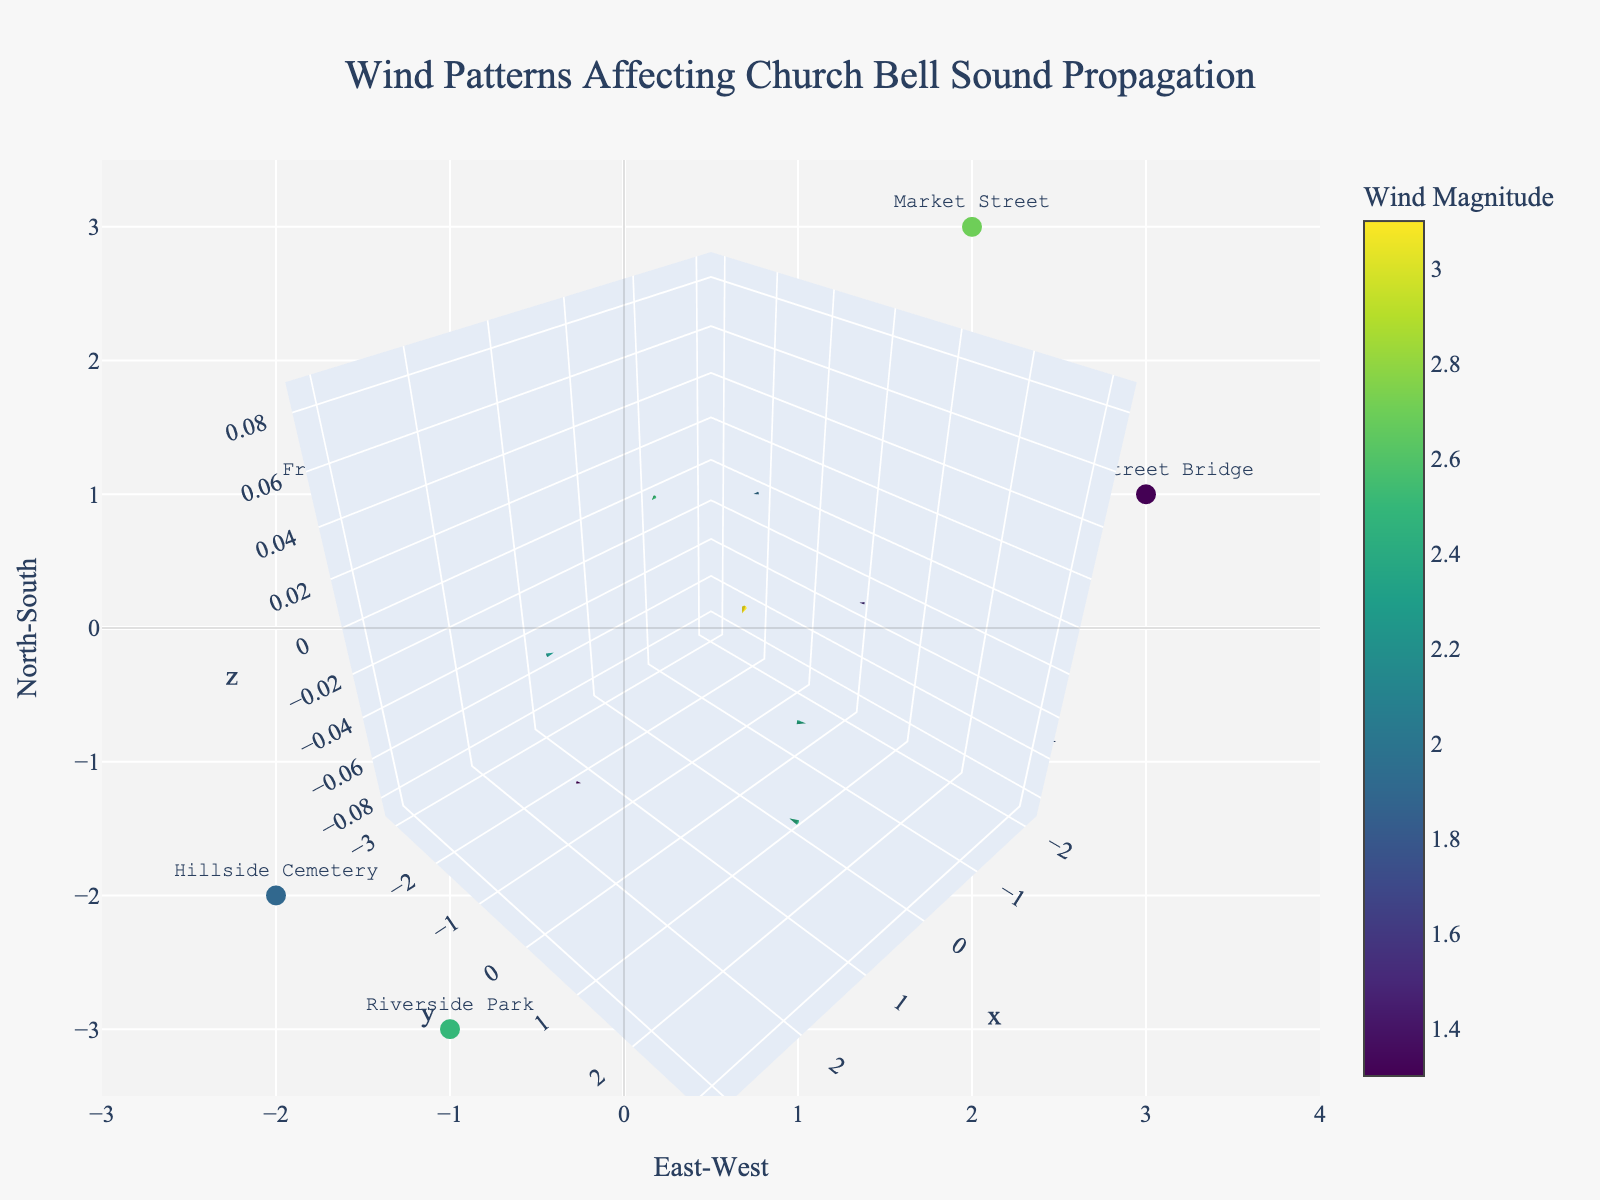How many locations are shown in the plot? There are markers scattered across the locations, each representing one point. Counting the number of names listed for locations, we find that the total number is 8.
Answer: 8 Which location exhibits the highest wind magnitude? The color of the markers indicates the wind magnitude, with Market Street showing the highest magnitude because its color halfway up the colorscale implies the highest value.
Answer: Market Street What direction does the wind move at the Old Mill Creek? Observing the arrow for Old Mill Creek, we see it points leftward (westward) with a slight upward tilt. Therefore, the wind direction is west-northwest.
Answer: West-northwest Compare the wind magnitudes at St. Mary's Church and Riverside Park; which is stronger? The marker colors for magnitude are compared, with St. Mary's Church showing a lighter color than Riverside Park. This means Riverside Park has a stronger wind magnitude.
Answer: Riverside Park What is the average wind magnitude across all locations? All given magnitudes are 3.1, 2.6, 1.7, 2.2, 1.9, 1.3, 2.5, 2.7. Summing these gives 3.1 + 2.6 + 1.7 + 2.2 + 1.9 + 1.3 + 2.5 + 2.7 = 18, and dividing by the number of locations (8), the average magnitude is 18/8.
Answer: 2.25 Which location has the wind blowing in the opposite direction of St. Mary's Church? The arrow at St. Mary's Church points to the northeast (NE), implying the wind blows toward the northeast. The wind at Old Mill Creek blows to the west-northwest (WNW), which is roughly opposite to NE.
Answer: Old Mill Creek Is the wind at Fr. De Peaux Memorial Garden moving faster or slower than the wind at Town Square? Compearing the lengths of vectors and colors, Fr. De Peaux Memorial Garden has a darker color (lower magnitude) than Town Square, showing that the wind at Fr. De Peaux Memorial Garden is slower.
Answer: Slower Which direction does the wind at Riverside Park flow compared to Hillside Cemetery? Observing the arrows, Riverside Park's wind shows a northeast (NE) direction while Hillside Cemetery displays a west-southwest (WSW) direction. They move in roughly opposite directions.
Answer: Opposite How does the wind direction at Market Street compare to the wind direction at Town Square? The arrows indicate that the wind at Market Street moves to the southeast, whereas at Town Square, it moves to the northeast. Therefore, the directions are different but not completely opposite.
Answer: Different 